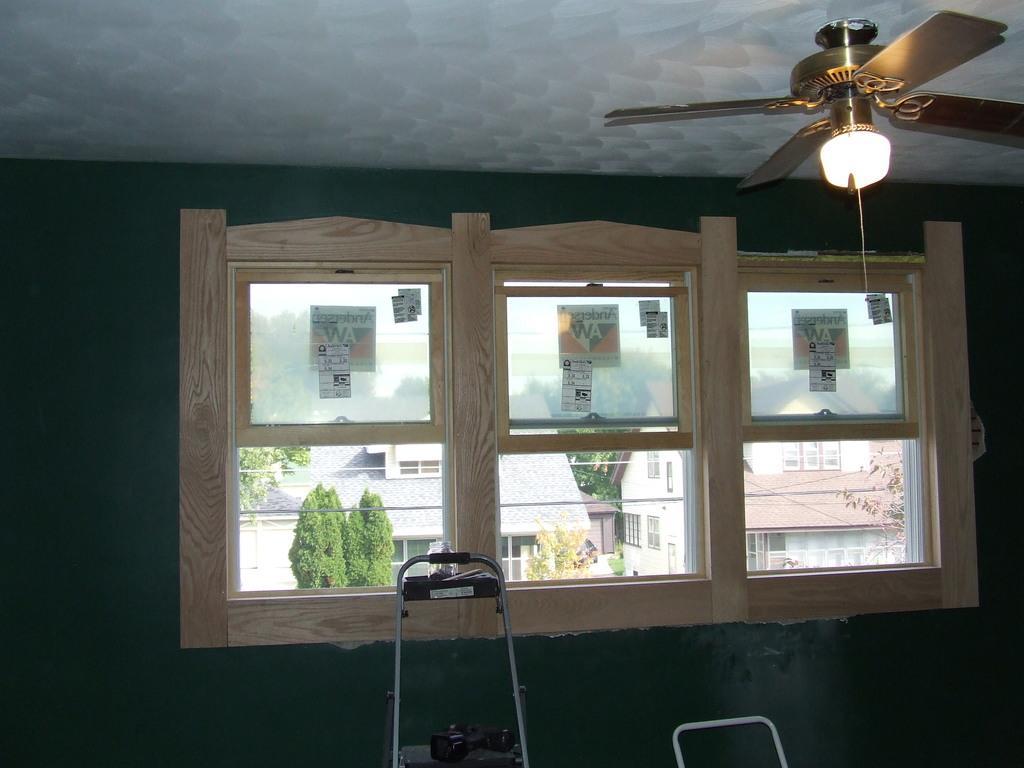Please provide a concise description of this image. In this image we can see a wall. Also there are windows. On the windows many things are passed. On the ceiling there is a fan with a light. At the bottom there is a stand. On the stand there is an object. Through the windows we can see trees and buildings with windows. 